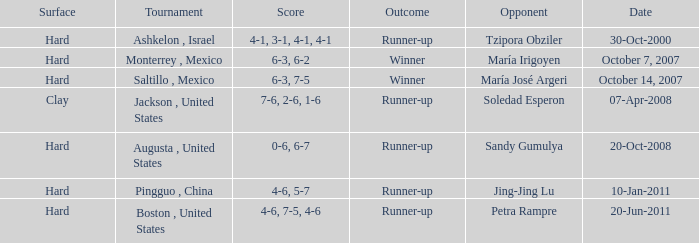Which tournament was held on October 14, 2007? Saltillo , Mexico. 